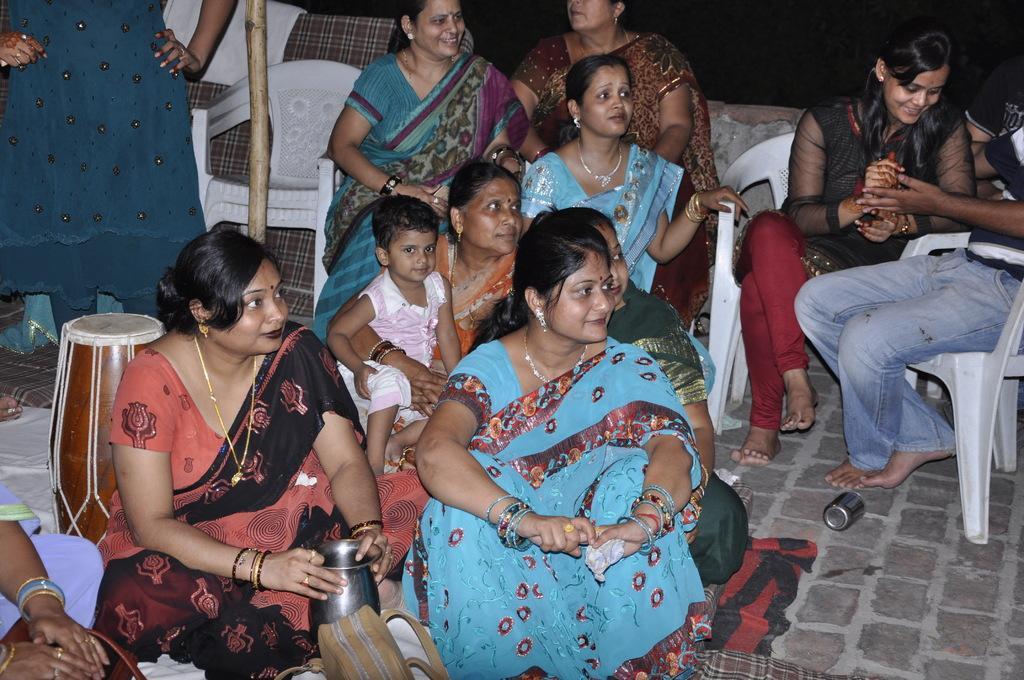Could you give a brief overview of what you see in this image? In this picture there are several peoples sitting on chairs and floor , a musical instrument is to the left of the image. 